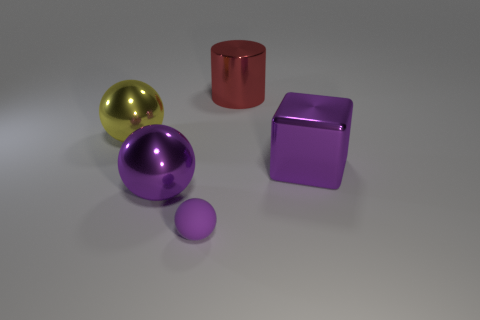Add 4 large purple cubes. How many objects exist? 9 Subtract all large metallic balls. How many balls are left? 1 Subtract all cyan blocks. How many purple spheres are left? 2 Subtract all spheres. How many objects are left? 2 Subtract all gray spheres. Subtract all gray cubes. How many spheres are left? 3 Subtract 0 red blocks. How many objects are left? 5 Subtract all yellow matte objects. Subtract all tiny rubber objects. How many objects are left? 4 Add 1 red objects. How many red objects are left? 2 Add 5 big yellow objects. How many big yellow objects exist? 6 